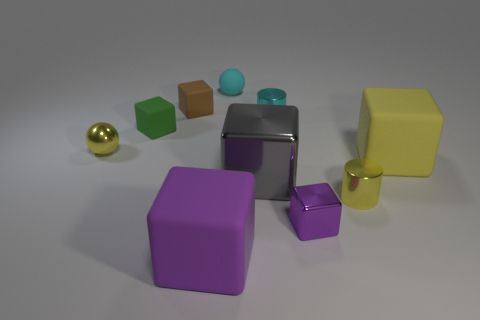Subtract 1 cubes. How many cubes are left? 5 Subtract all small green blocks. How many blocks are left? 5 Subtract all brown cubes. How many cubes are left? 5 Subtract all red cubes. Subtract all red cylinders. How many cubes are left? 6 Subtract all cubes. How many objects are left? 4 Add 3 big red balls. How many big red balls exist? 3 Subtract 0 red blocks. How many objects are left? 10 Subtract all big metal things. Subtract all gray metallic blocks. How many objects are left? 8 Add 3 small balls. How many small balls are left? 5 